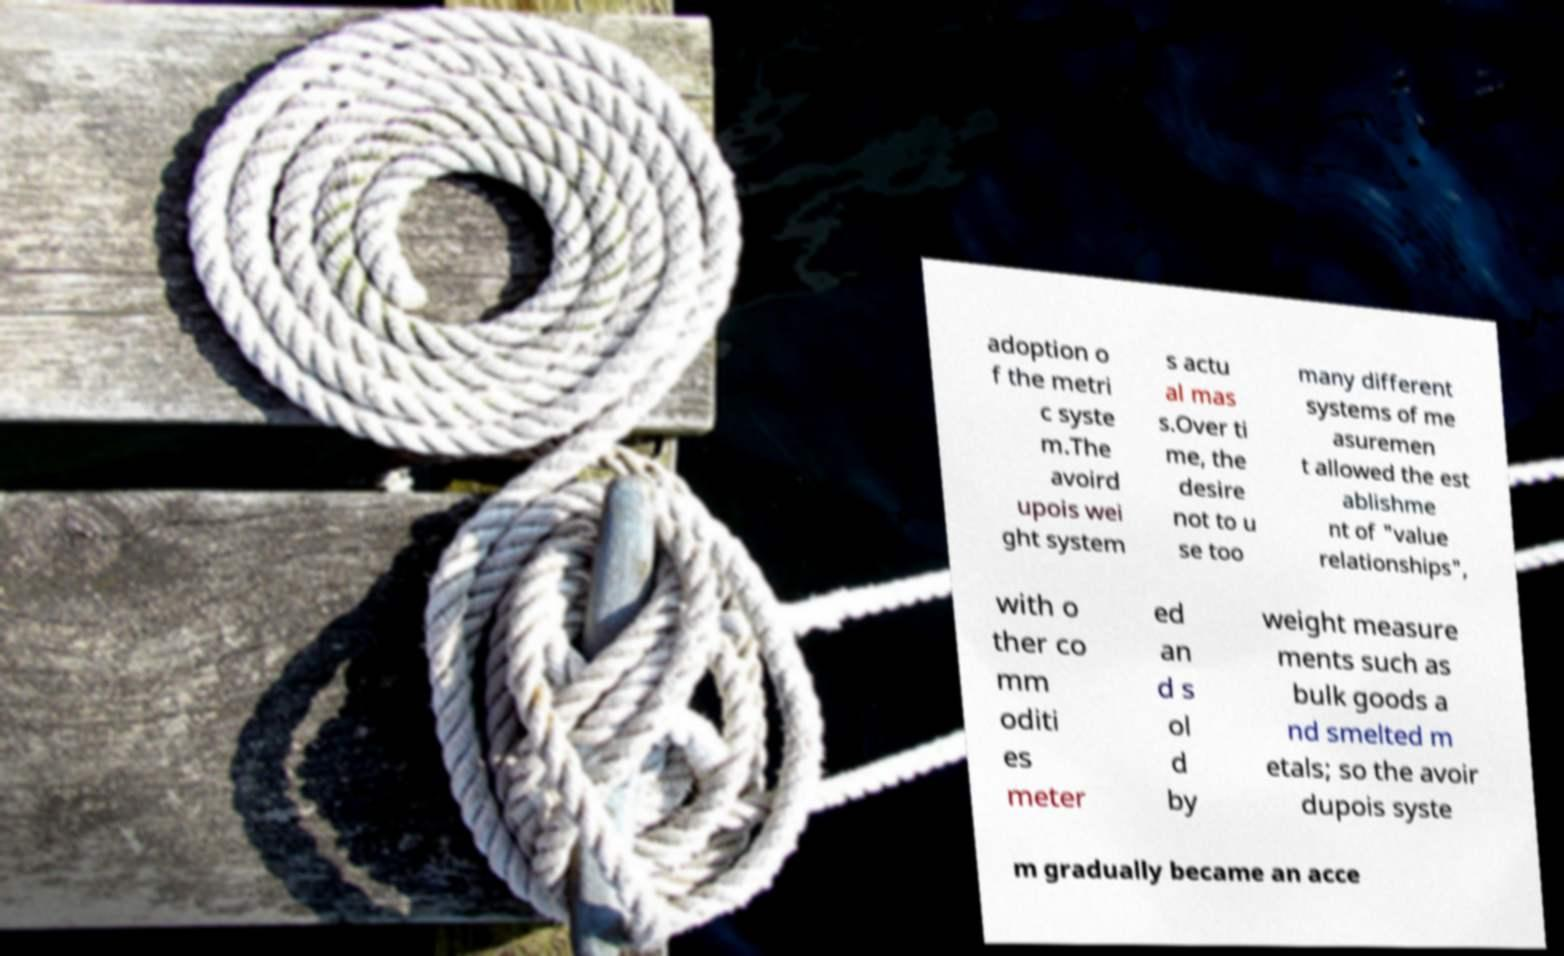Can you read and provide the text displayed in the image?This photo seems to have some interesting text. Can you extract and type it out for me? adoption o f the metri c syste m.The avoird upois wei ght system s actu al mas s.Over ti me, the desire not to u se too many different systems of me asuremen t allowed the est ablishme nt of "value relationships", with o ther co mm oditi es meter ed an d s ol d by weight measure ments such as bulk goods a nd smelted m etals; so the avoir dupois syste m gradually became an acce 